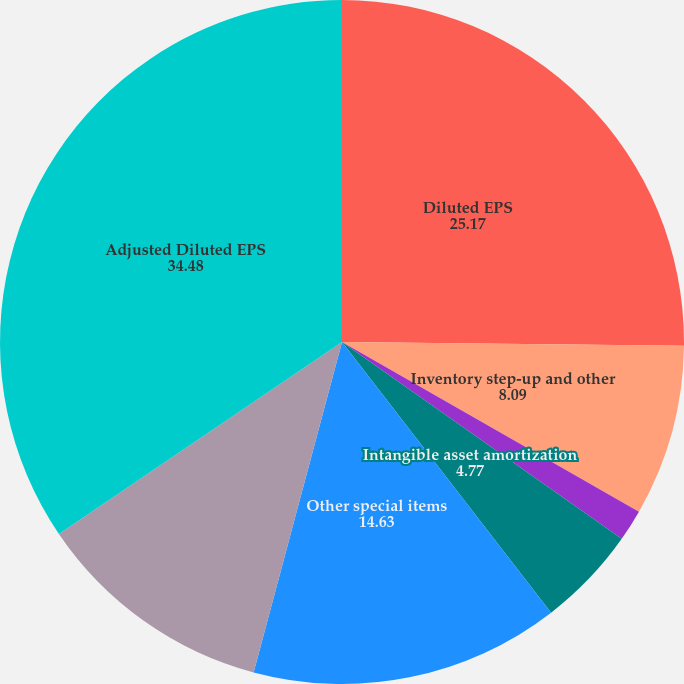Convert chart. <chart><loc_0><loc_0><loc_500><loc_500><pie_chart><fcel>Diluted EPS<fcel>Inventory step-up and other<fcel>Certain claims<fcel>Intangible asset amortization<fcel>Other special items<fcel>Taxes on above items and other<fcel>Adjusted Diluted EPS<nl><fcel>25.17%<fcel>8.09%<fcel>1.5%<fcel>4.77%<fcel>14.63%<fcel>11.36%<fcel>34.48%<nl></chart> 